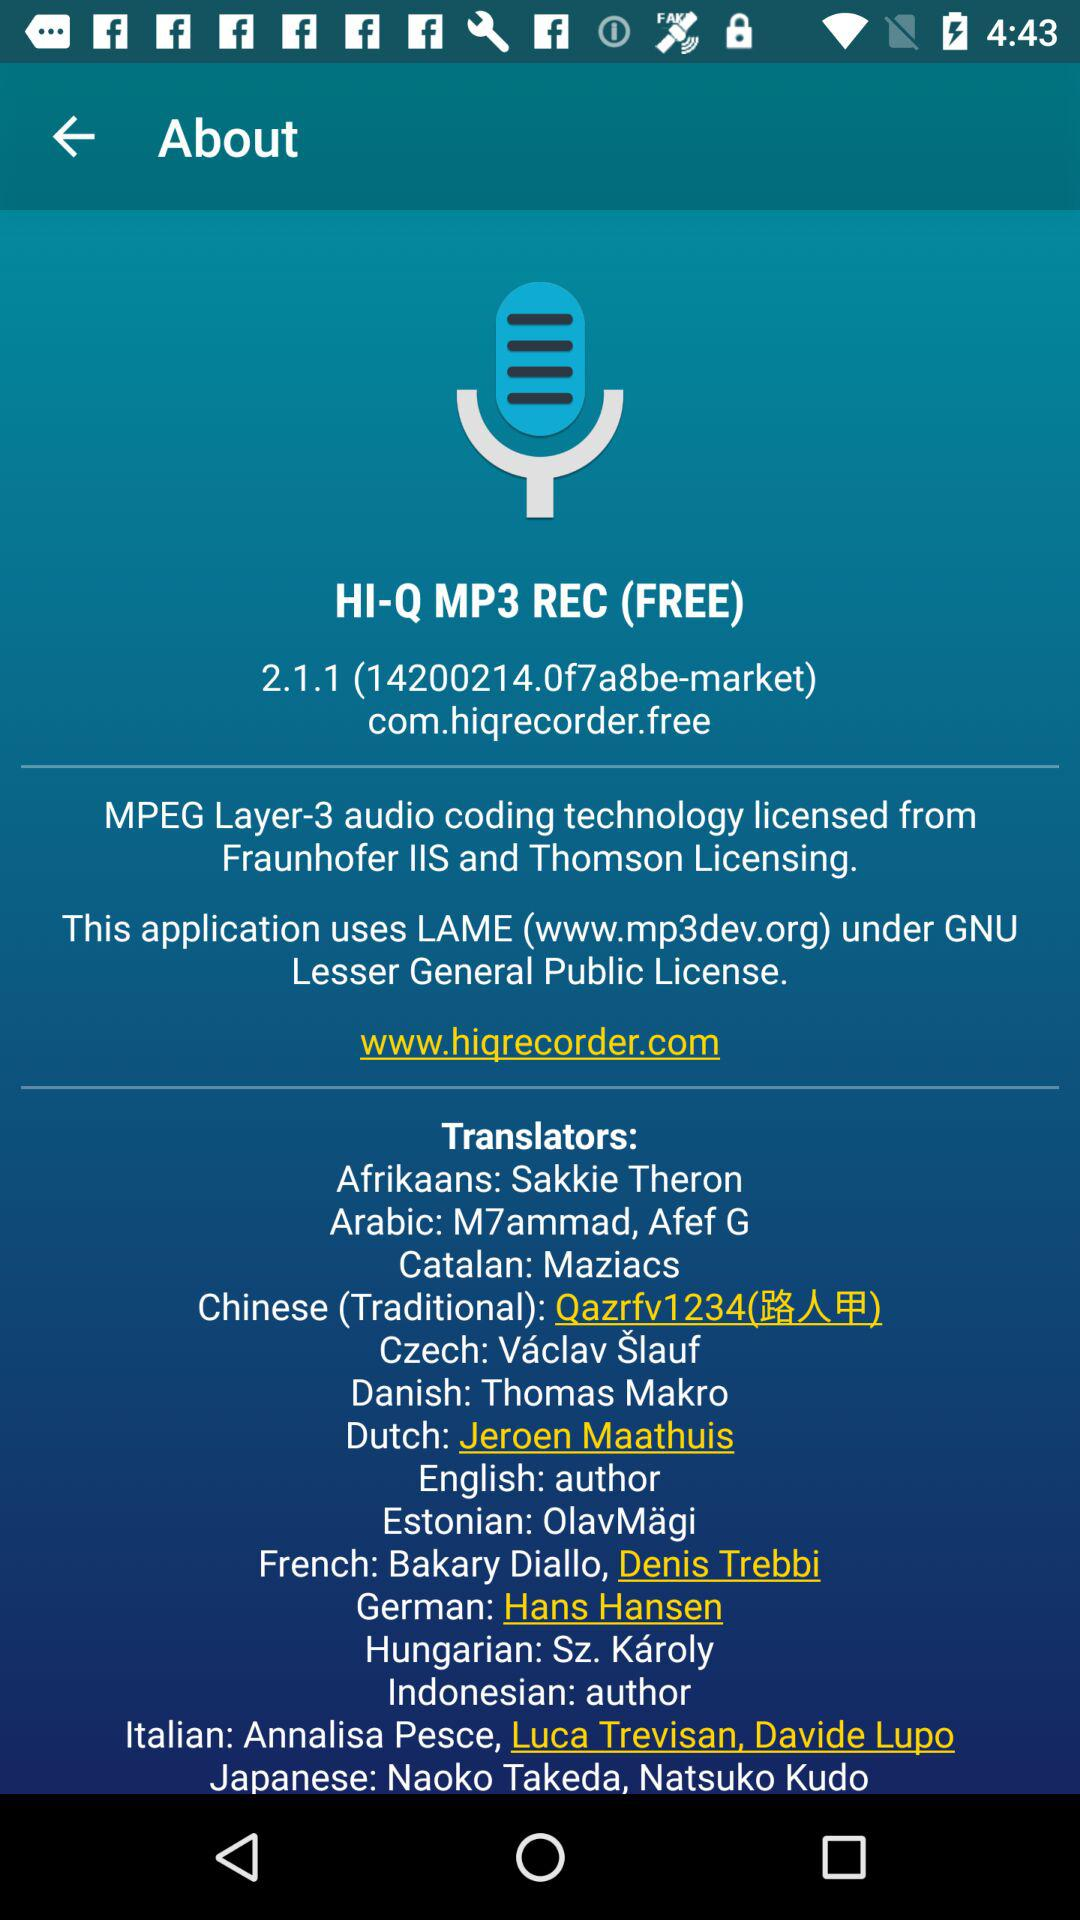What technology is used in the application? The technology used in the application is MPEG Layer-3 audio coding. 